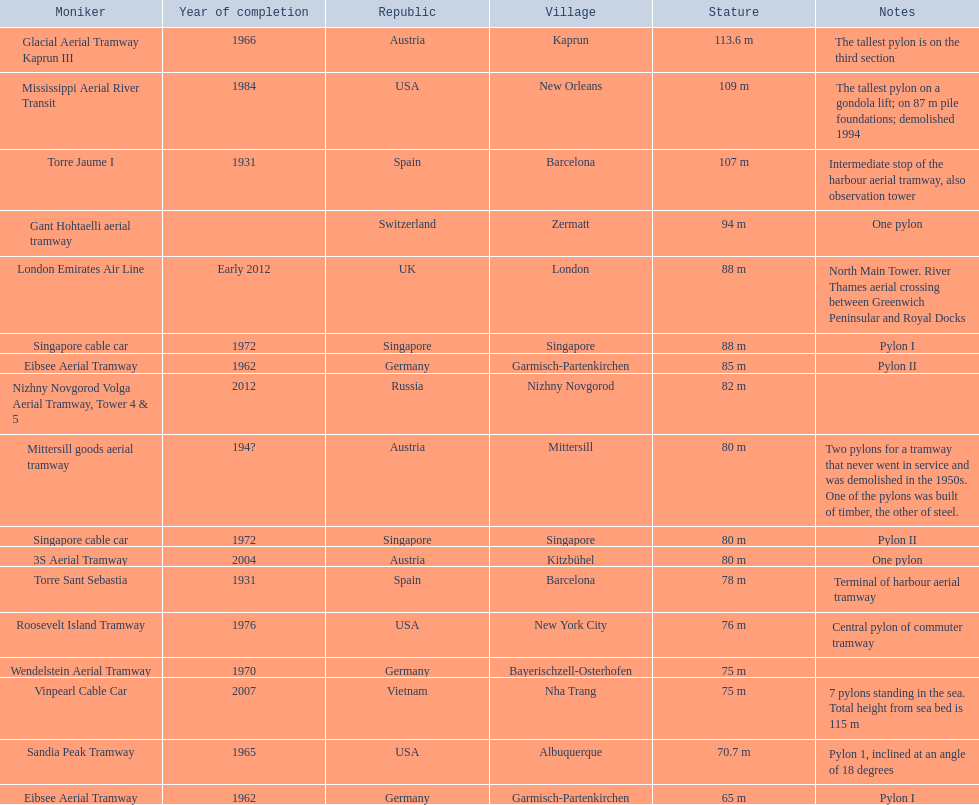Which lift has the second highest height? Mississippi Aerial River Transit. What is the value of the height? 109 m. 